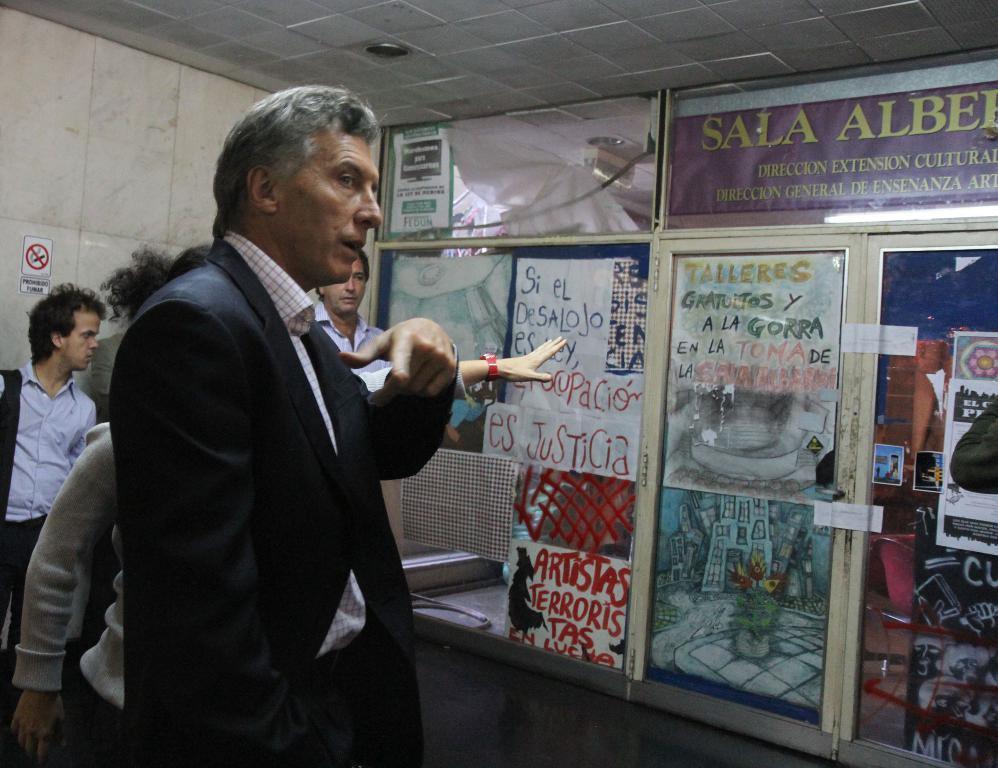Who or what can be seen in the image? There are people in the image. What is on the walls in the image? There are posters on the walls. What is visible in the background of the image? There is a wall and a door visible in the background of the image. Can you see a bike being ridden by someone in the image? There is no bike present in the image. 